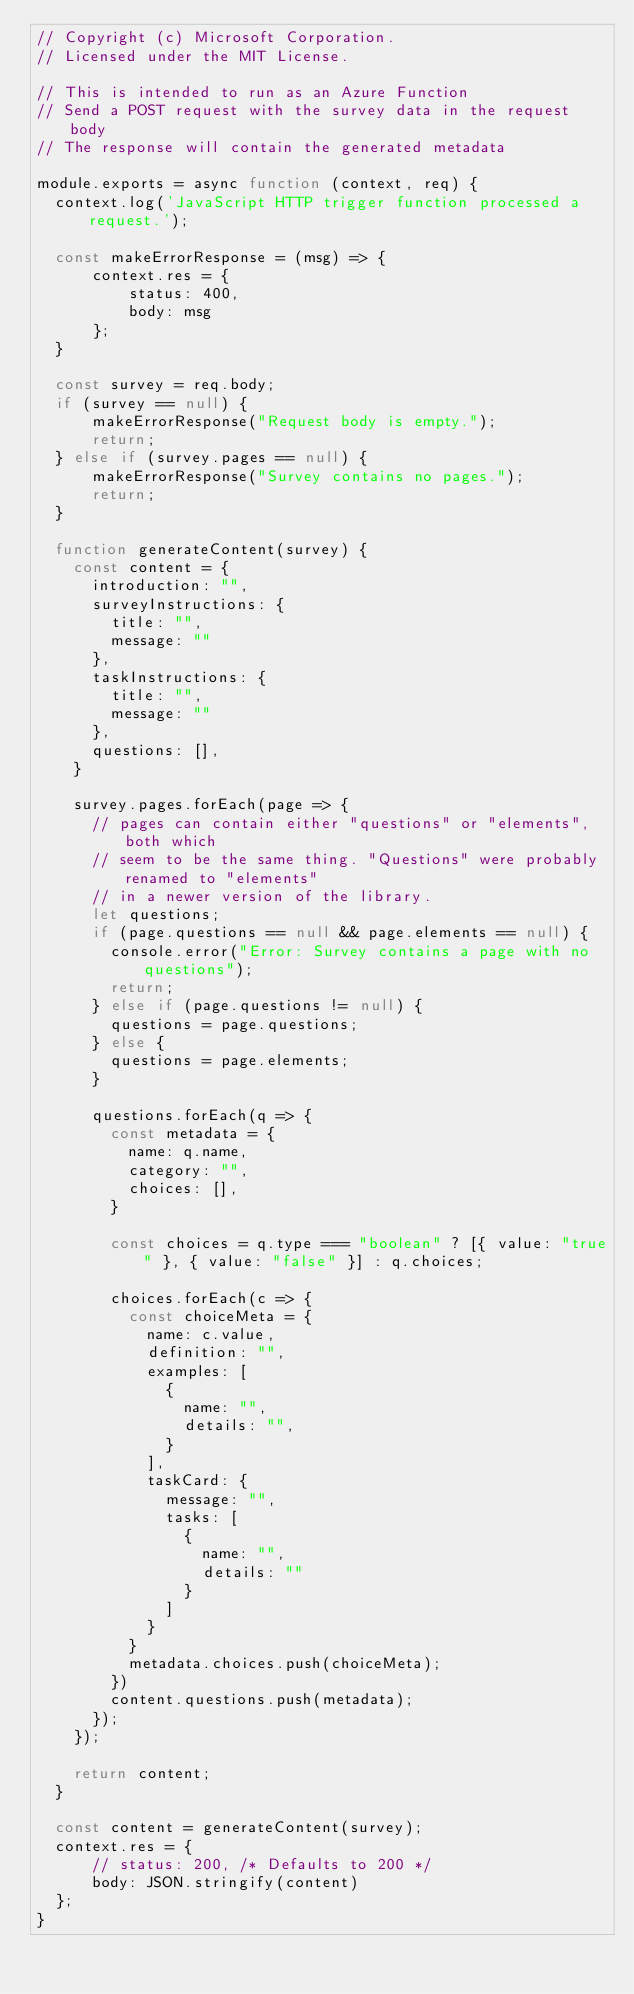<code> <loc_0><loc_0><loc_500><loc_500><_JavaScript_>// Copyright (c) Microsoft Corporation.
// Licensed under the MIT License.

// This is intended to run as an Azure Function
// Send a POST request with the survey data in the request body
// The response will contain the generated metadata

module.exports = async function (context, req) {
  context.log('JavaScript HTTP trigger function processed a request.');

  const makeErrorResponse = (msg) => {
      context.res = {
          status: 400,
          body: msg
      };
  }

  const survey = req.body;
  if (survey == null) {
      makeErrorResponse("Request body is empty.");
      return;
  } else if (survey.pages == null) {
      makeErrorResponse("Survey contains no pages.");
      return;
  }

  function generateContent(survey) {
    const content = {
      introduction: "",
      surveyInstructions: {
        title: "",
        message: ""
      },
      taskInstructions: {
        title: "",
        message: ""
      },
      questions: [],
    }
  
    survey.pages.forEach(page => {
      // pages can contain either "questions" or "elements", both which
      // seem to be the same thing. "Questions" were probably renamed to "elements"
      // in a newer version of the library.
      let questions;
      if (page.questions == null && page.elements == null) {
        console.error("Error: Survey contains a page with no questions");
        return;
      } else if (page.questions != null) {
        questions = page.questions;
      } else {
        questions = page.elements;
      }
  
      questions.forEach(q => {
        const metadata = {
          name: q.name,
          category: "",
          choices: [],
        }
  
        const choices = q.type === "boolean" ? [{ value: "true" }, { value: "false" }] : q.choices;
  
        choices.forEach(c => {
          const choiceMeta = {
            name: c.value,
            definition: "",
            examples: [
              {
                name: "",
                details: "",
              }
            ],
            taskCard: {
              message: "",
              tasks: [
                {
                  name: "",
                  details: ""
                }
              ]
            }
          }
          metadata.choices.push(choiceMeta);
        })
        content.questions.push(metadata);
      });
    });
  
    return content;
  }

  const content = generateContent(survey);
  context.res = {
      // status: 200, /* Defaults to 200 */
      body: JSON.stringify(content)
  };
}</code> 